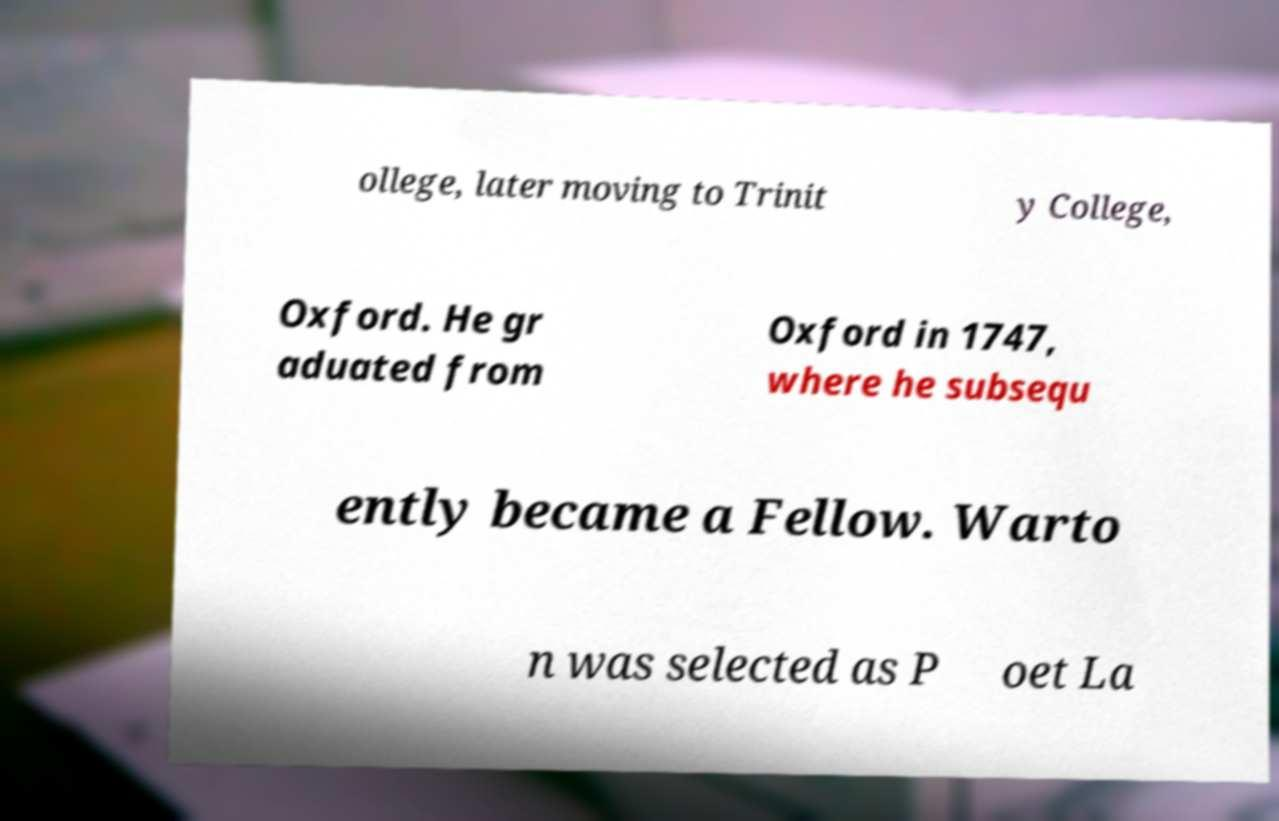Could you assist in decoding the text presented in this image and type it out clearly? ollege, later moving to Trinit y College, Oxford. He gr aduated from Oxford in 1747, where he subsequ ently became a Fellow. Warto n was selected as P oet La 